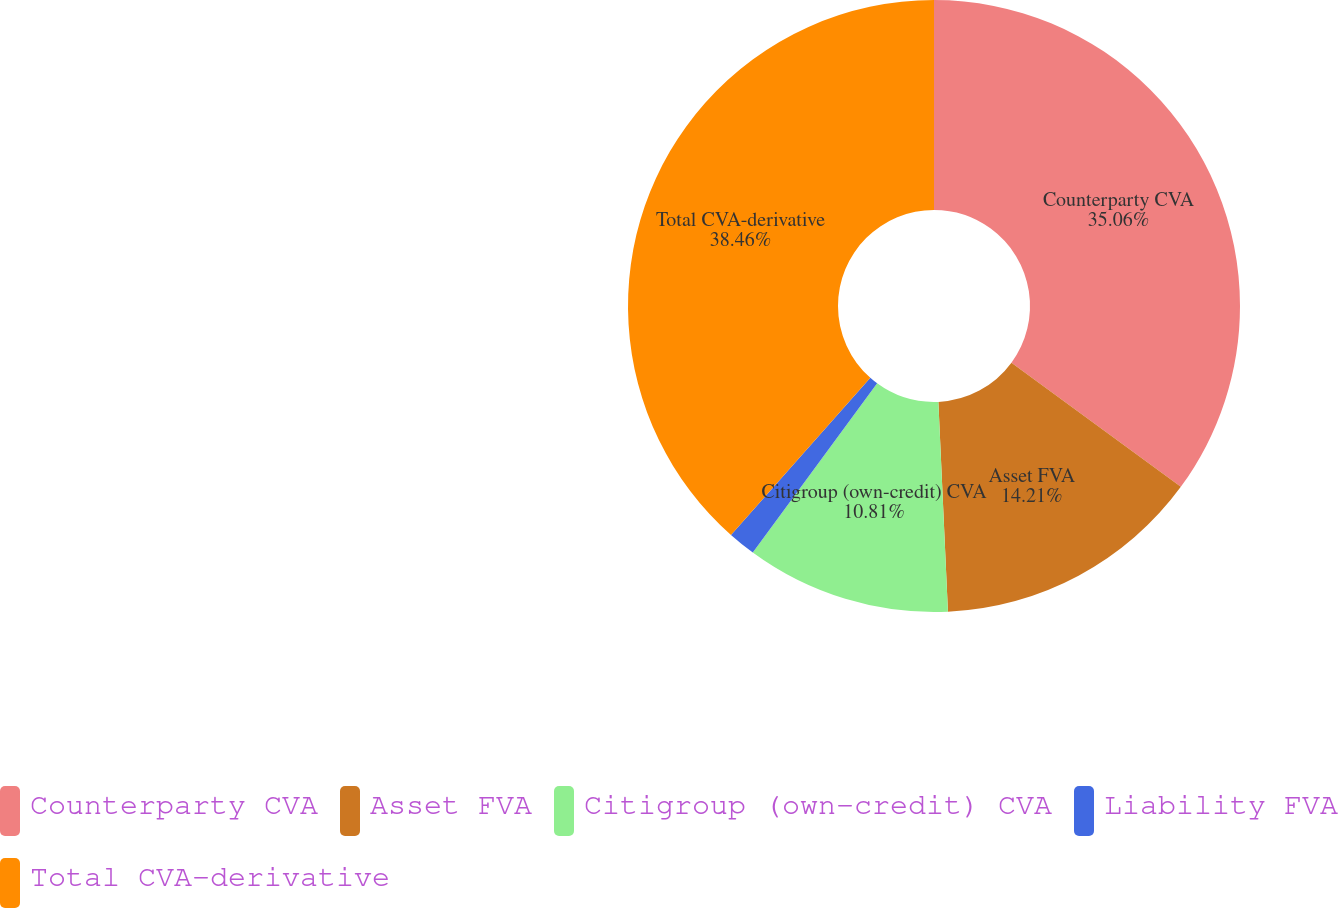<chart> <loc_0><loc_0><loc_500><loc_500><pie_chart><fcel>Counterparty CVA<fcel>Asset FVA<fcel>Citigroup (own-credit) CVA<fcel>Liability FVA<fcel>Total CVA-derivative<nl><fcel>35.06%<fcel>14.21%<fcel>10.81%<fcel>1.46%<fcel>38.45%<nl></chart> 